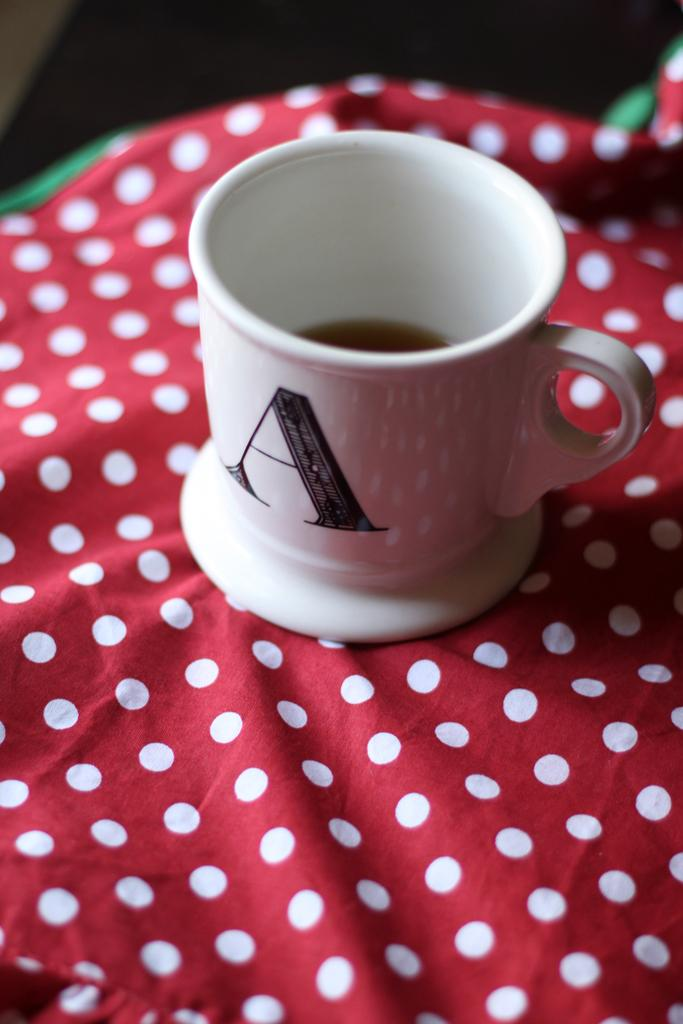<image>
Present a compact description of the photo's key features. A coffee mug monogrammed with the letter A is sitting on a polka dot cloth. 